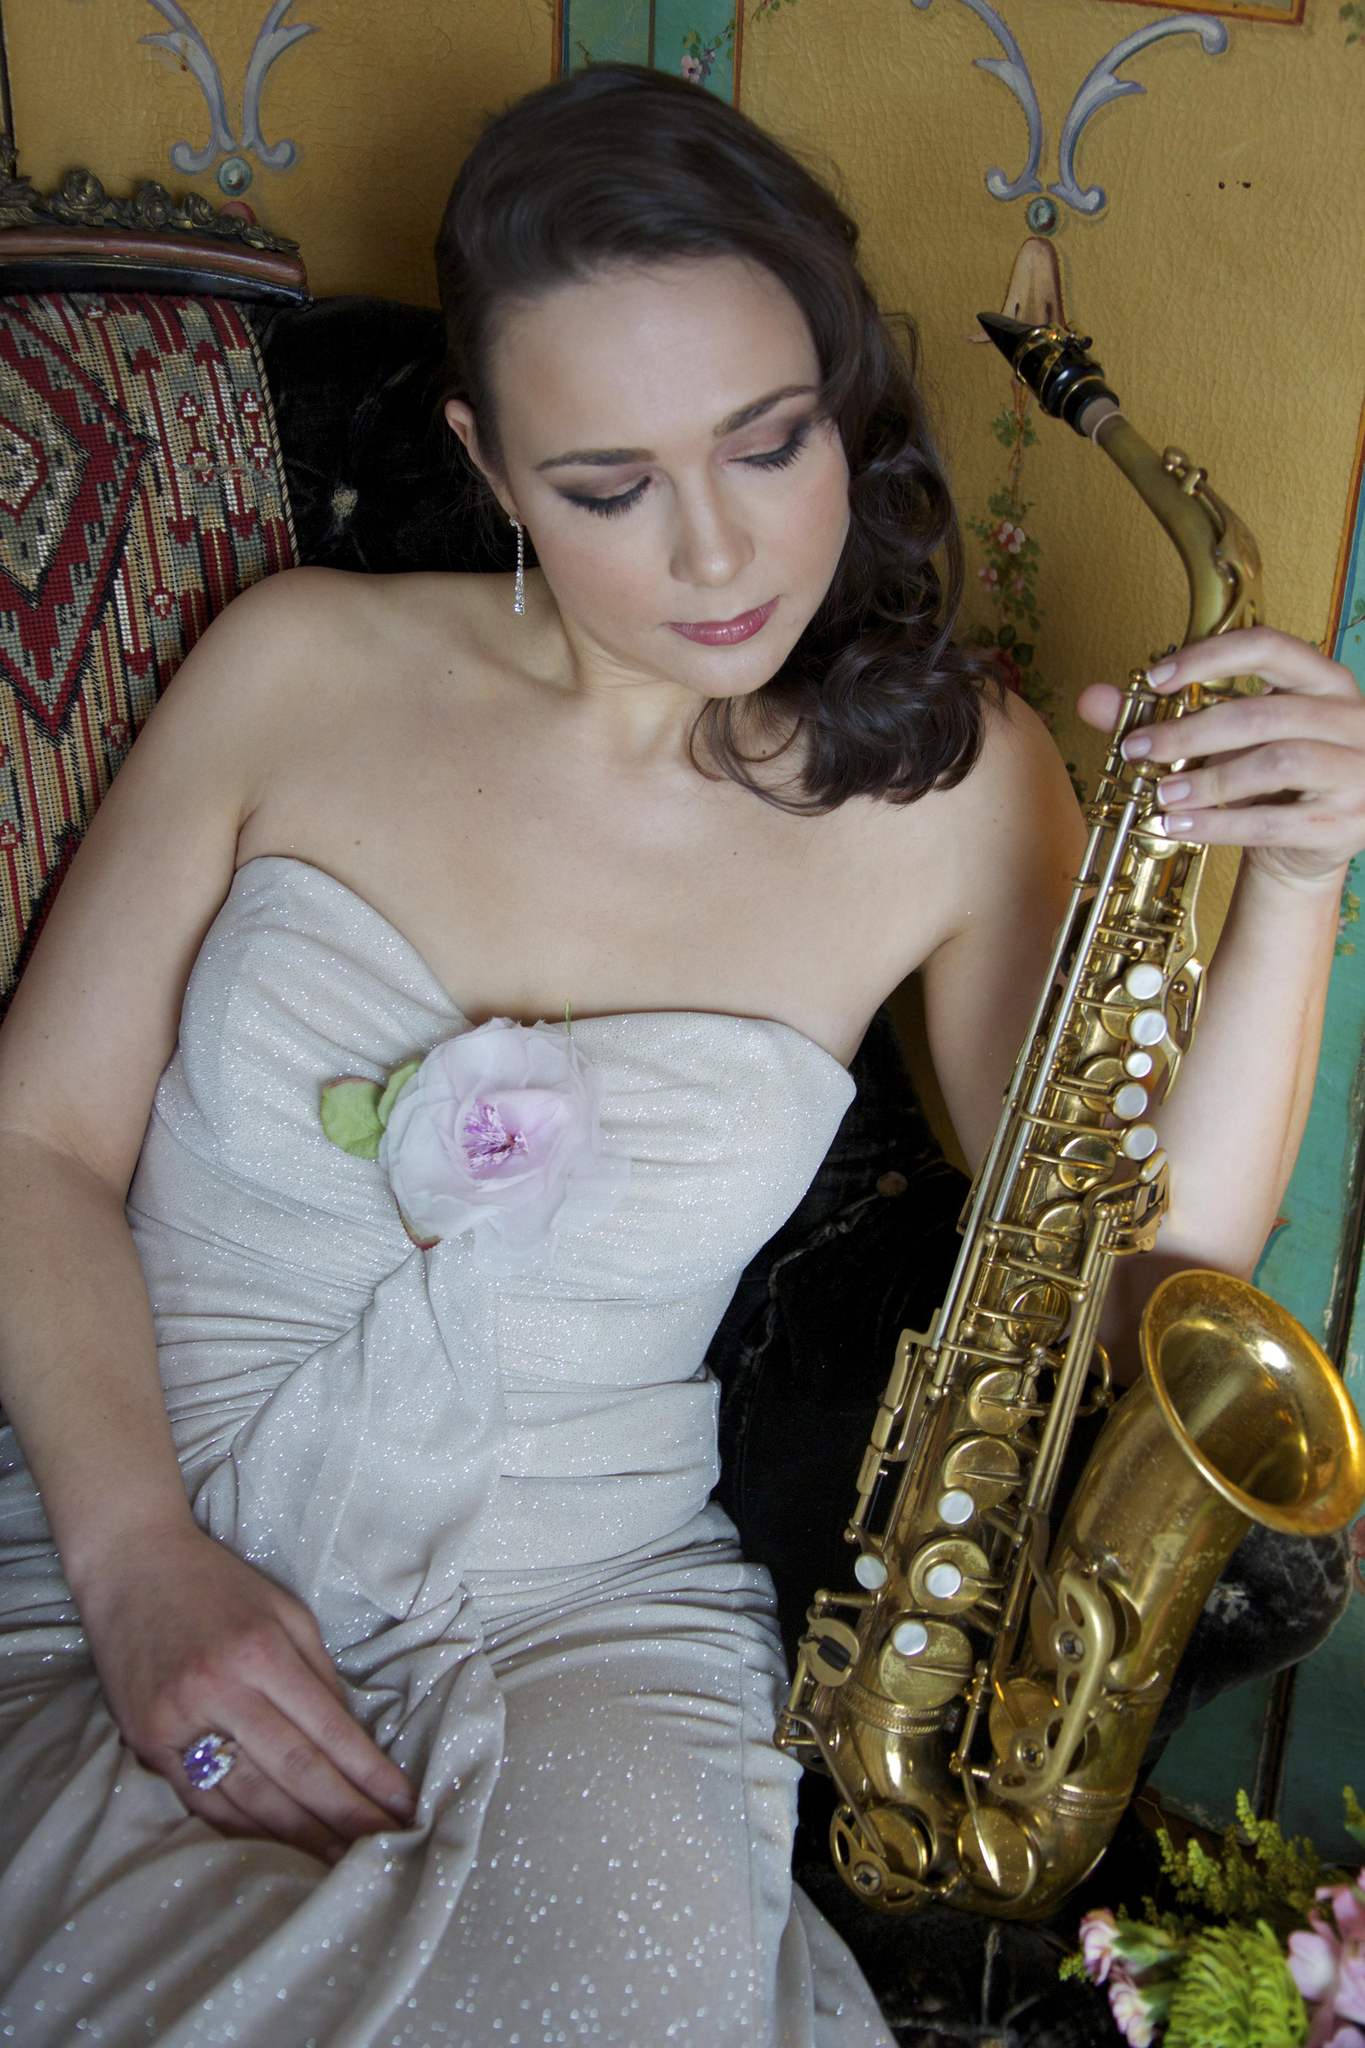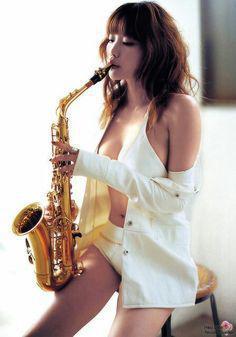The first image is the image on the left, the second image is the image on the right. Given the left and right images, does the statement "There are no more than three people in the pair of images." hold true? Answer yes or no. Yes. The first image is the image on the left, the second image is the image on the right. For the images shown, is this caption "At least one woman appears to be actively playing a saxophone." true? Answer yes or no. Yes. 